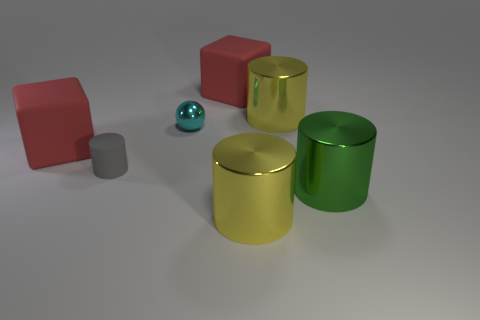How many other objects are the same shape as the gray object?
Give a very brief answer. 3. Do the yellow shiny cylinder in front of the large green object and the gray matte cylinder on the left side of the small cyan ball have the same size?
Give a very brief answer. No. How many balls are either big green things or large matte things?
Your answer should be very brief. 0. How many matte things are tiny spheres or small objects?
Offer a terse response. 1. What is the size of the gray thing that is the same shape as the green object?
Your response must be concise. Small. There is a metallic sphere; does it have the same size as the red object that is to the left of the gray object?
Make the answer very short. No. There is a rubber thing behind the cyan object; what shape is it?
Provide a succinct answer. Cube. There is a shiny sphere in front of the metallic cylinder that is behind the tiny cylinder; what color is it?
Keep it short and to the point. Cyan. There is another small object that is the same shape as the green object; what is its color?
Give a very brief answer. Gray. There is a thing that is both left of the big green metallic cylinder and in front of the small gray rubber object; what is its shape?
Offer a terse response. Cylinder. 